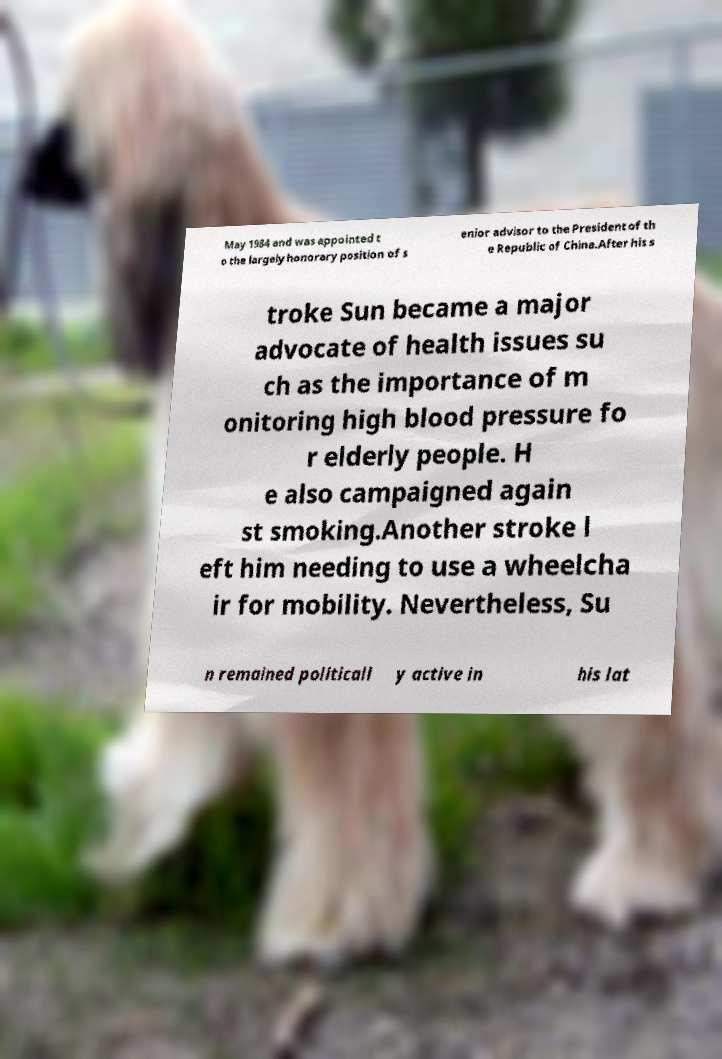For documentation purposes, I need the text within this image transcribed. Could you provide that? May 1984 and was appointed t o the largely honorary position of s enior advisor to the President of th e Republic of China.After his s troke Sun became a major advocate of health issues su ch as the importance of m onitoring high blood pressure fo r elderly people. H e also campaigned again st smoking.Another stroke l eft him needing to use a wheelcha ir for mobility. Nevertheless, Su n remained politicall y active in his lat 